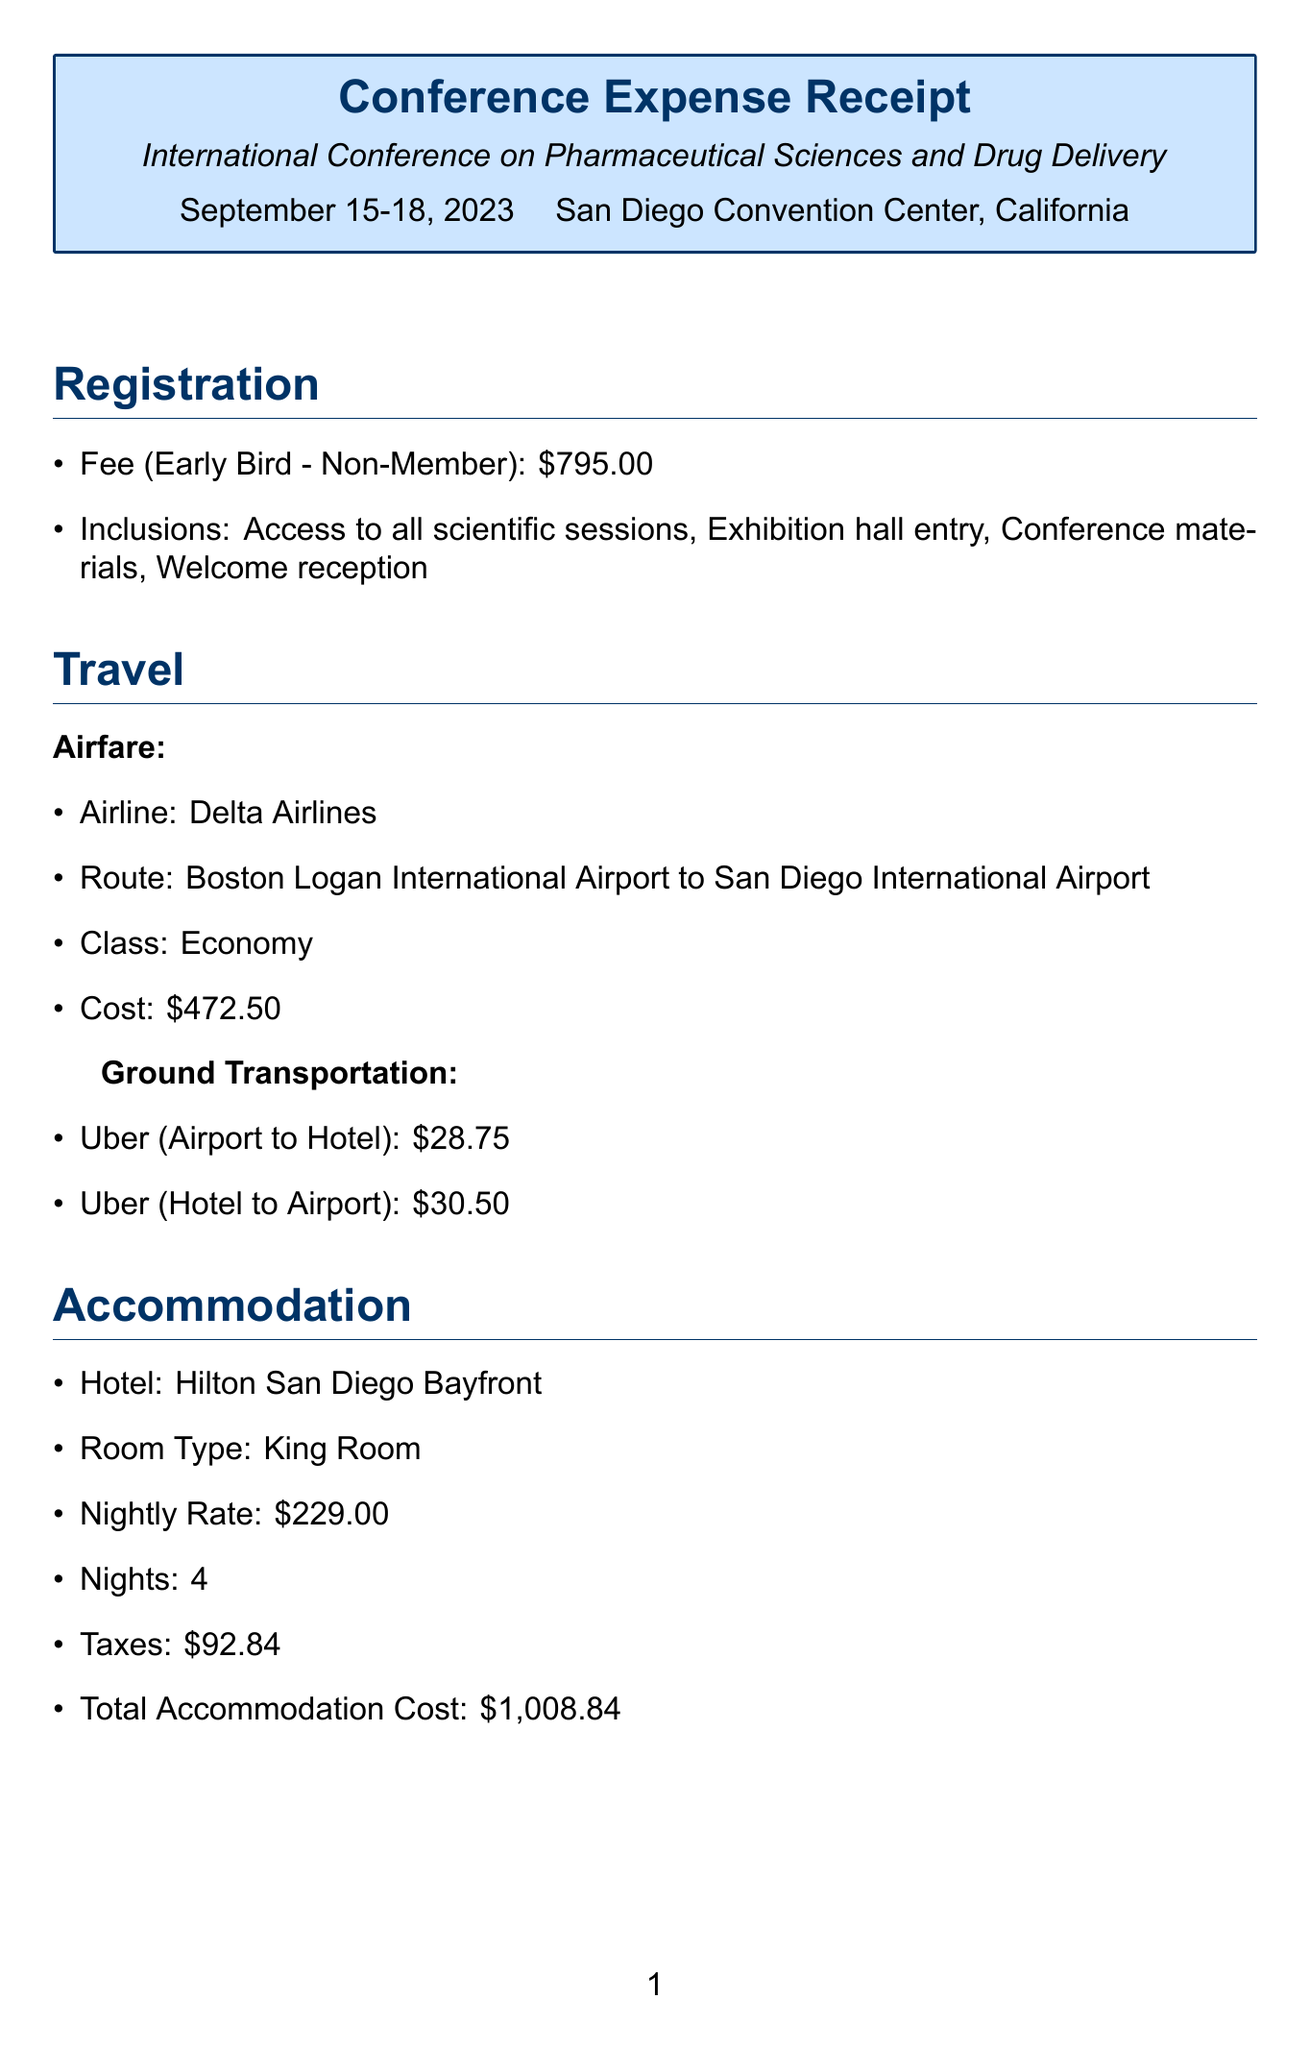what is the conference name? The conference name is stated in the document under conference details.
Answer: International Conference on Pharmaceutical Sciences and Drug Delivery what is the registration fee? The registration fee can be found under the registration section of the document.
Answer: 795 how many nights was accommodation booked for? The number of nights can be located in the accommodation section.
Answer: 4 what was the total accommodation cost? The total accommodation cost is clearly mentioned in the accommodation section.
Answer: 1008.84 what is the total meals cost? The total meals cost is summarized in the meals section of the document.
Answer: 304 how much was spent on the workshop about alternative drug delivery methods? The cost for the workshop can be found in the additional expenses section.
Answer: 150 what is the total expenses for attending the conference? The total expenses are provided at the end of the document.
Answer: 2924.59 which airline was used for airfare? The airline name is explicitly mentioned in the travel section.
Answer: Delta Airlines what is included in the registration fee? The inclusions are listed under the registration section.
Answer: Access to all scientific sessions, Exhibition hall entry, Conference materials, Welcome reception 